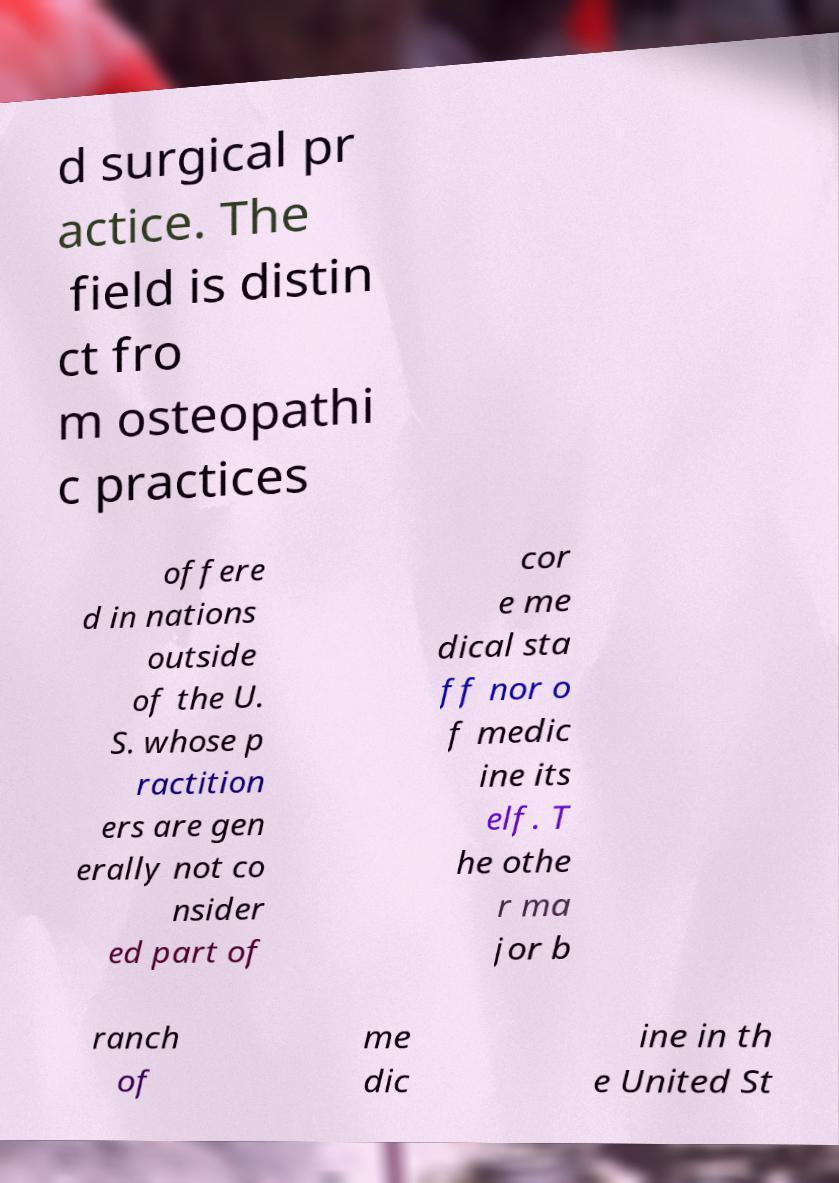Please identify and transcribe the text found in this image. d surgical pr actice. The field is distin ct fro m osteopathi c practices offere d in nations outside of the U. S. whose p ractition ers are gen erally not co nsider ed part of cor e me dical sta ff nor o f medic ine its elf. T he othe r ma jor b ranch of me dic ine in th e United St 